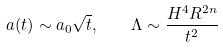<formula> <loc_0><loc_0><loc_500><loc_500>a ( t ) \sim a _ { 0 } \sqrt { t } , \quad \Lambda \sim \frac { H ^ { 4 } R ^ { 2 n } } { t ^ { 2 } }</formula> 